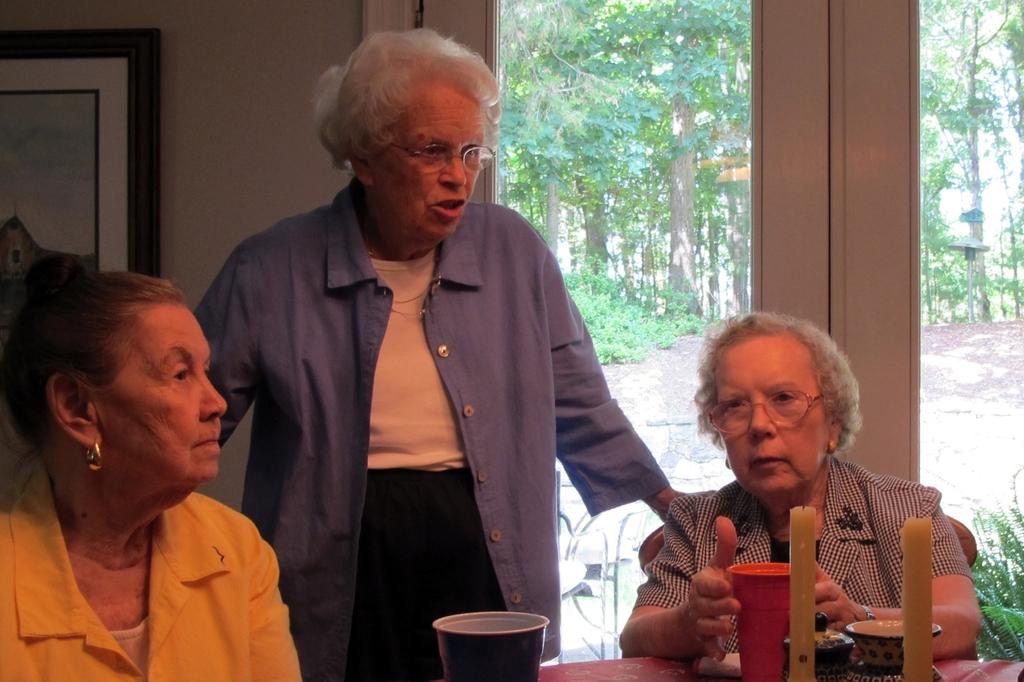Who or what can be seen in the image? There are people in the image. What is on the table in the image? There are objects on a table in the image. What is hanging on the wall in the image? There is a painting on a wall in the image. What allows light to enter the room in the image? There is a glass window in the image. What type of vegetation is visible in the image? Trees are visible in the image. What can people sit on in the image? Chairs are present in the image. What type of noise can be heard coming from the beast in the image? There is no beast present in the image, and therefore no such noise can be heard. What news source is mentioned in the image? There is no mention of a news source in the image. 